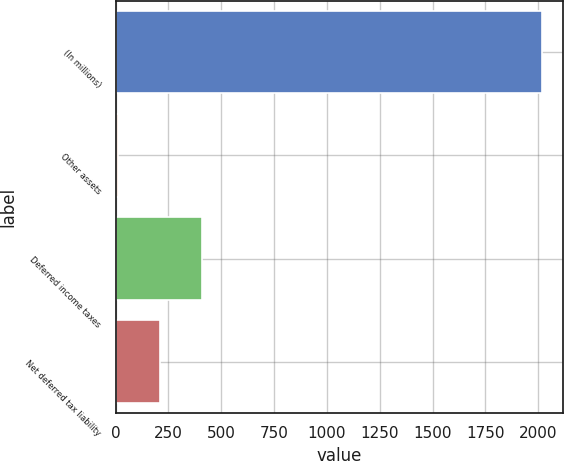Convert chart. <chart><loc_0><loc_0><loc_500><loc_500><bar_chart><fcel>(In millions)<fcel>Other assets<fcel>Deferred income taxes<fcel>Net deferred tax liability<nl><fcel>2017<fcel>9.4<fcel>410.92<fcel>210.16<nl></chart> 